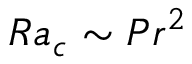Convert formula to latex. <formula><loc_0><loc_0><loc_500><loc_500>R a _ { c } \sim P r ^ { 2 }</formula> 